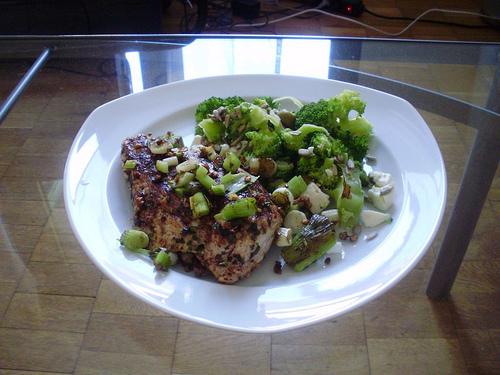What color is the plate?
Be succinct. White. What vegetable is served with the meat?
Short answer required. Broccoli. Is there a rug on the floor?
Answer briefly. No. Is there chicken on the plate?
Give a very brief answer. Yes. 